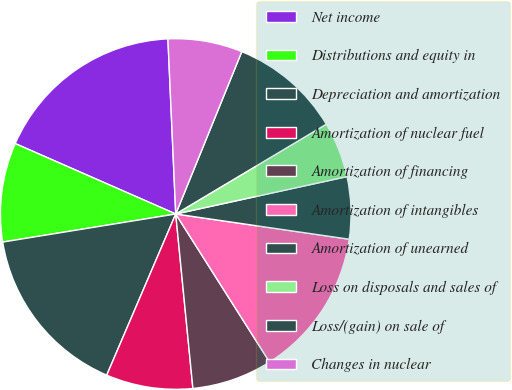Convert chart. <chart><loc_0><loc_0><loc_500><loc_500><pie_chart><fcel>Net income<fcel>Distributions and equity in<fcel>Depreciation and amortization<fcel>Amortization of nuclear fuel<fcel>Amortization of financing<fcel>Amortization of intangibles<fcel>Amortization of unearned<fcel>Loss on disposals and sales of<fcel>Loss/(gain) on sale of<fcel>Changes in nuclear<nl><fcel>17.71%<fcel>9.14%<fcel>16.0%<fcel>8.0%<fcel>7.43%<fcel>13.71%<fcel>5.72%<fcel>5.14%<fcel>10.29%<fcel>6.86%<nl></chart> 